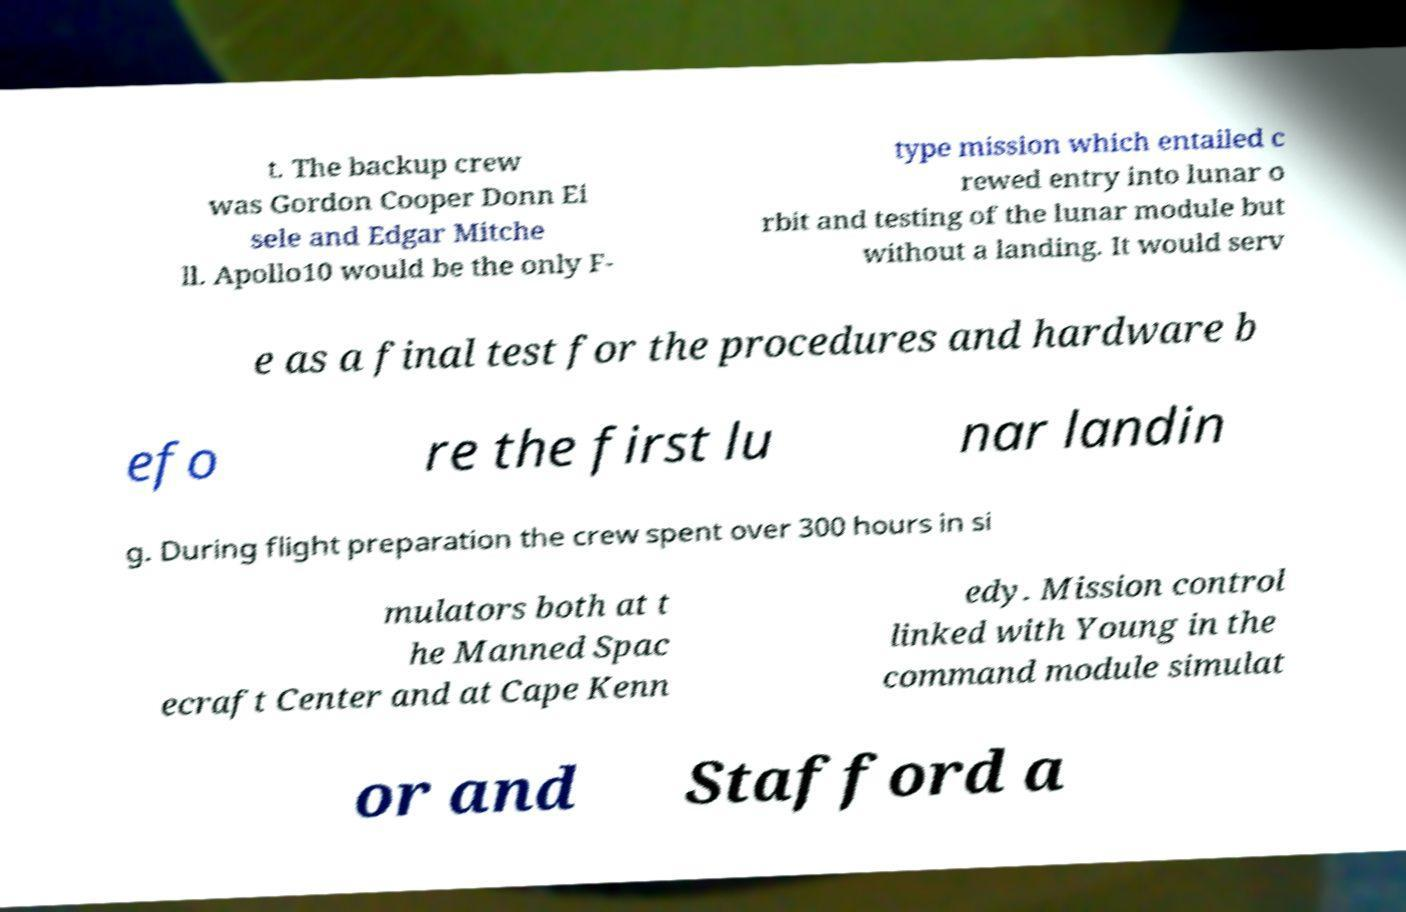Can you read and provide the text displayed in the image?This photo seems to have some interesting text. Can you extract and type it out for me? t. The backup crew was Gordon Cooper Donn Ei sele and Edgar Mitche ll. Apollo10 would be the only F- type mission which entailed c rewed entry into lunar o rbit and testing of the lunar module but without a landing. It would serv e as a final test for the procedures and hardware b efo re the first lu nar landin g. During flight preparation the crew spent over 300 hours in si mulators both at t he Manned Spac ecraft Center and at Cape Kenn edy. Mission control linked with Young in the command module simulat or and Stafford a 